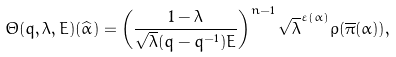<formula> <loc_0><loc_0><loc_500><loc_500>\Theta ( q , \lambda , E ) ( \widehat { \alpha } ) = \left ( \frac { 1 - \lambda } { \sqrt { \lambda } ( q - q ^ { - 1 } ) E } \right ) ^ { n - 1 } \sqrt { \lambda } ^ { \varepsilon ( \alpha ) } \rho ( \overline { \pi } ( \alpha ) ) ,</formula> 